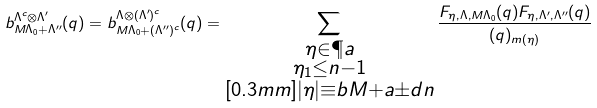Convert formula to latex. <formula><loc_0><loc_0><loc_500><loc_500>b ^ { \Lambda ^ { c } \otimes \Lambda ^ { \prime } } _ { M \Lambda _ { 0 } + \Lambda ^ { \prime \prime } } ( q ) = b ^ { \Lambda \otimes ( \Lambda ^ { \prime } ) ^ { c } } _ { M \Lambda _ { 0 } + ( \Lambda ^ { \prime \prime } ) ^ { c } } ( q ) = \sum _ { \substack { \eta \in \P a \\ \eta _ { 1 } \leq n - 1 \\ [ 0 . 3 m m ] | \eta | \equiv b M + a \pm d { n } } } \frac { F _ { \eta , \Lambda , M \Lambda _ { 0 } } ( q ) F _ { \eta , \Lambda ^ { \prime } , \Lambda ^ { \prime \prime } } ( q ) } { ( q ) _ { m ( \eta ) } }</formula> 